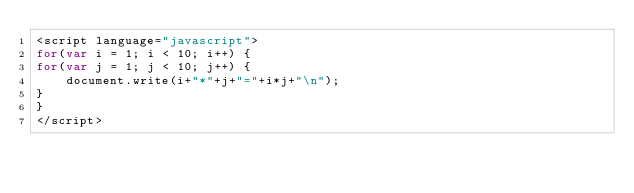Convert code to text. <code><loc_0><loc_0><loc_500><loc_500><_JavaScript_><script language="javascript">
for(var i = 1; i < 10; i++) {
for(var j = 1; j < 10; j++) {
    document.write(i+"*"+j+"="+i*j+"\n");
}
}
</script></code> 